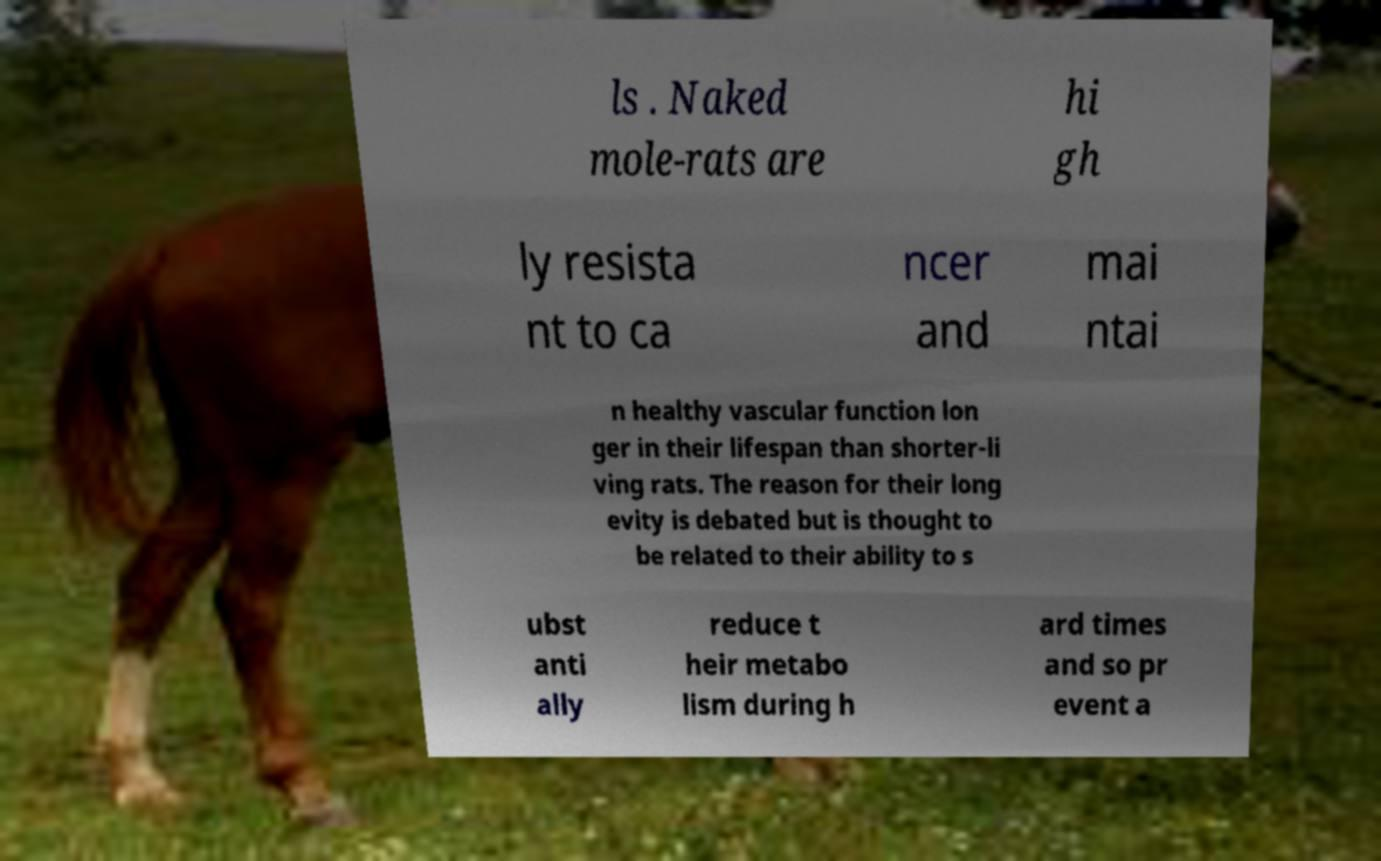For documentation purposes, I need the text within this image transcribed. Could you provide that? ls . Naked mole-rats are hi gh ly resista nt to ca ncer and mai ntai n healthy vascular function lon ger in their lifespan than shorter-li ving rats. The reason for their long evity is debated but is thought to be related to their ability to s ubst anti ally reduce t heir metabo lism during h ard times and so pr event a 